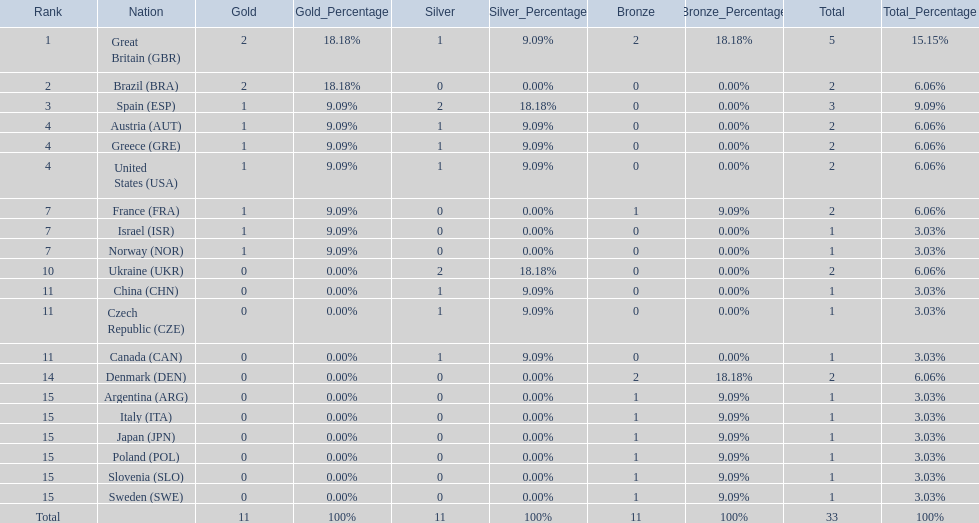Which nation received 2 silver medals? Spain (ESP), Ukraine (UKR). Of those, which nation also had 2 total medals? Spain (ESP). 